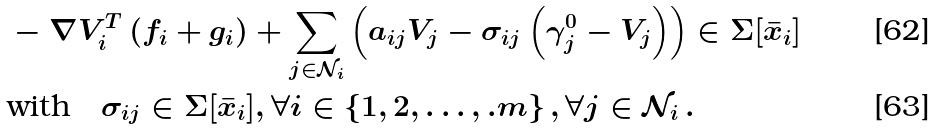Convert formula to latex. <formula><loc_0><loc_0><loc_500><loc_500>& - \nabla V _ { i } ^ { T } \left ( f _ { i } + g _ { i } \right ) + \sum _ { j \in \mathcal { N } _ { i } } \left ( a _ { i j } V _ { j } - \sigma _ { i j } \left ( \gamma _ { j } ^ { 0 } - V _ { j } \right ) \right ) \in \Sigma [ \bar { x } _ { i } ] \\ & \text {with} \quad \sigma _ { i j } \in \Sigma [ \bar { x } _ { i } ] , \forall i \in \left \{ 1 , 2 , \dots , . m \right \} , \forall j \in \mathcal { N } _ { i } \, .</formula> 